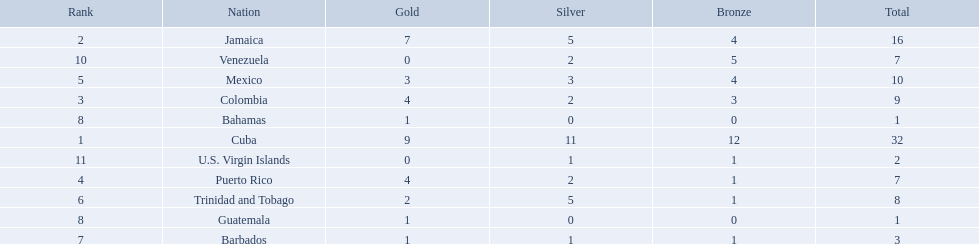Which 3 countries were awarded the most medals? Cuba, Jamaica, Colombia. Of these 3 countries which ones are islands? Cuba, Jamaica. Which one won the most silver medals? Cuba. 